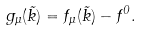<formula> <loc_0><loc_0><loc_500><loc_500>g _ { \mu } ( \vec { k } ) = f _ { \mu } ( \vec { k } ) - f ^ { 0 } .</formula> 